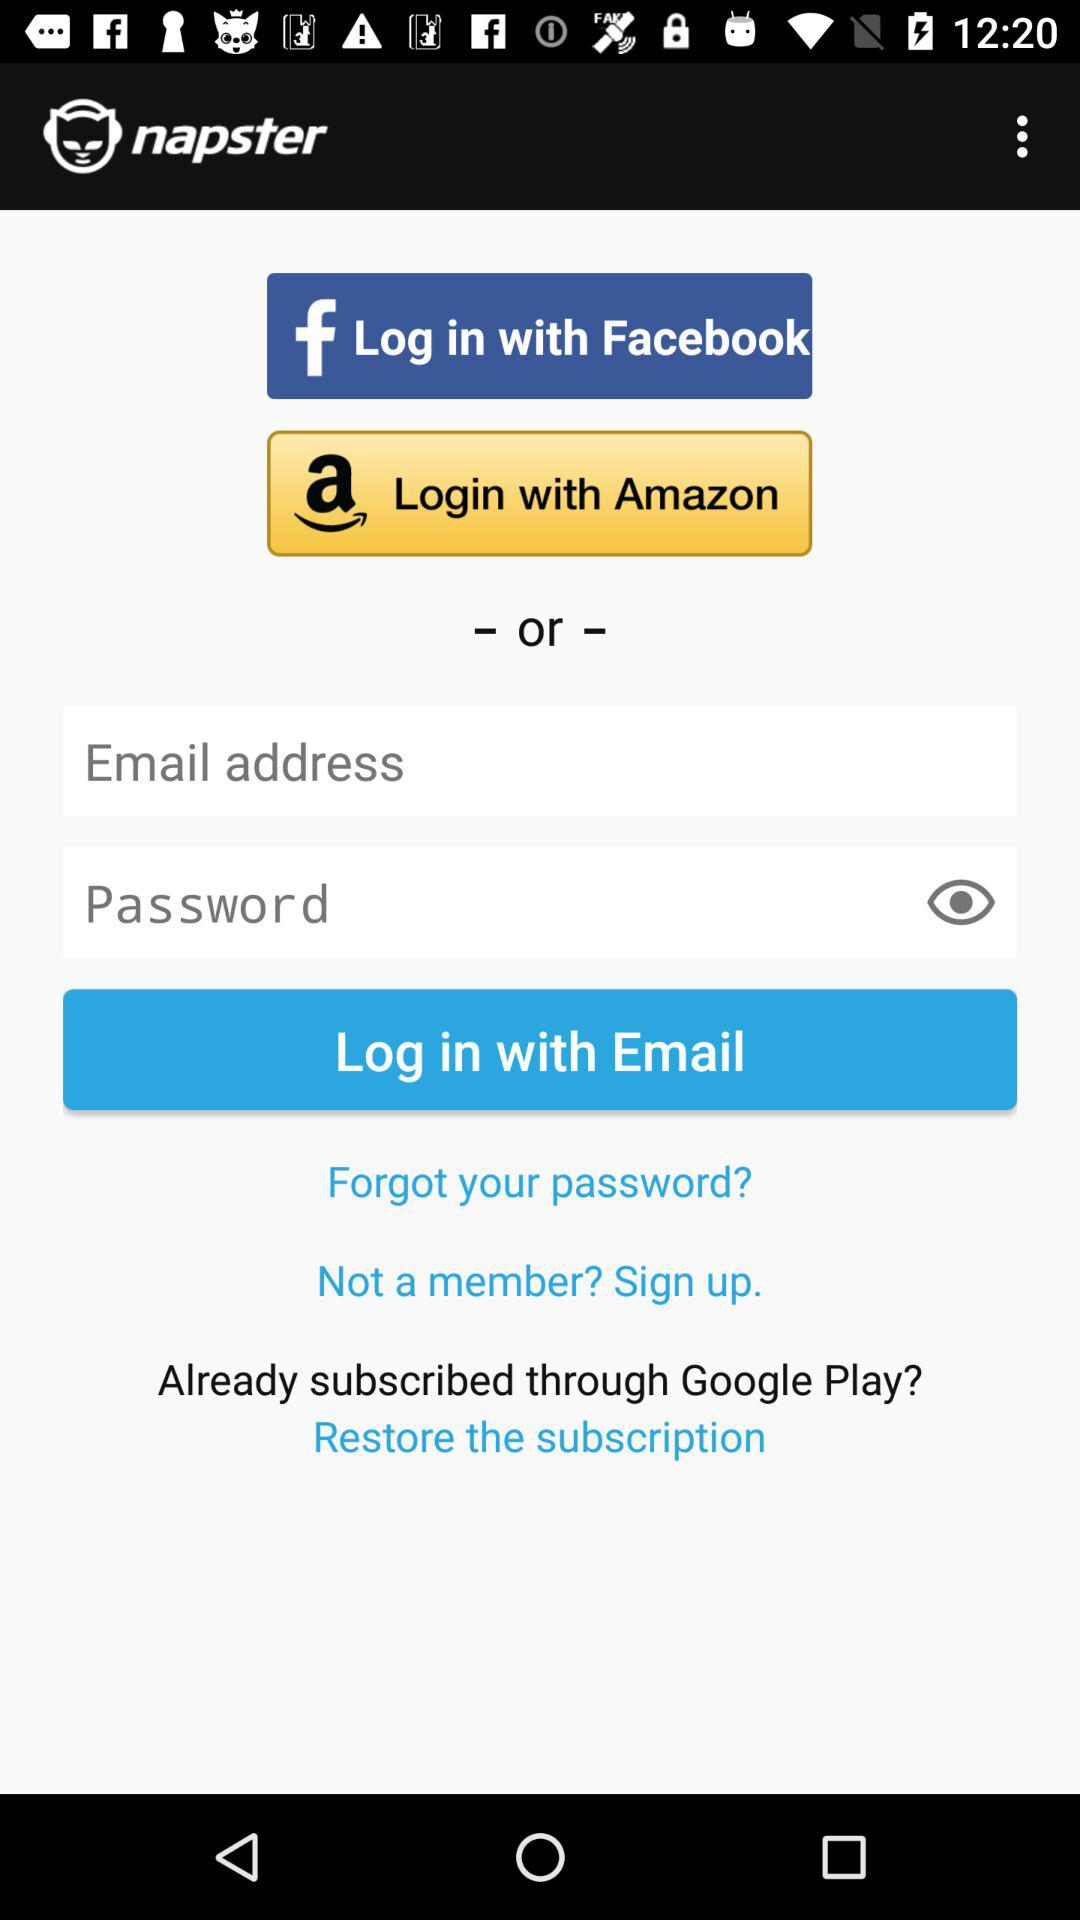What is the application name? The application name is "napster". 